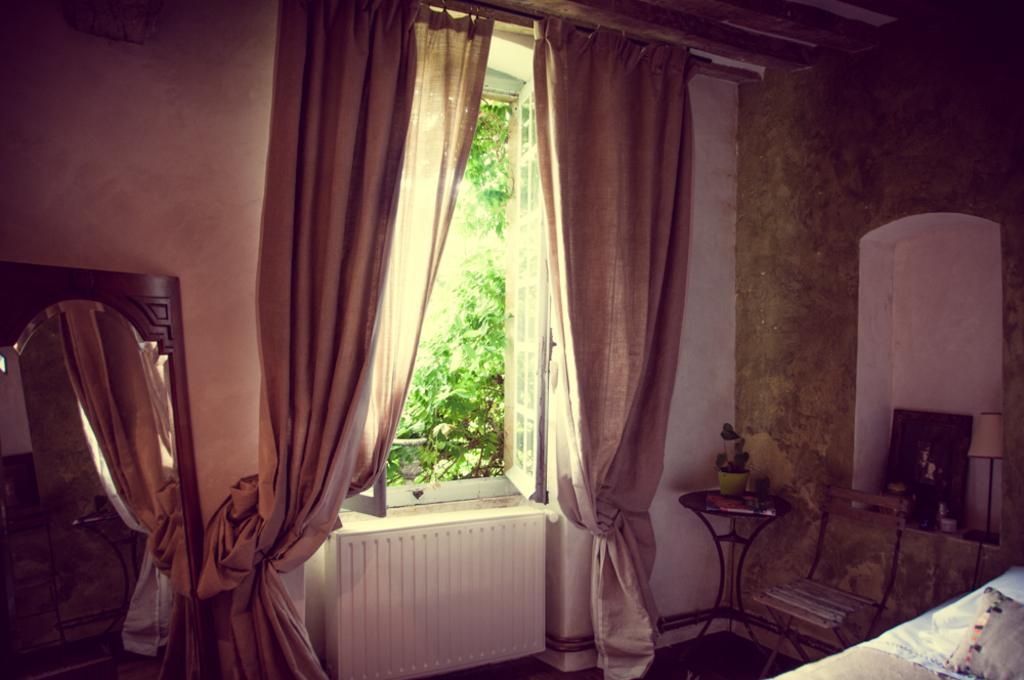What is present in the image that allows light to enter the room? There is a window in the image. What is used to cover or decorate the window? There are curtains associated with the window. What type of furniture is present in the image? There is a chair and a table in the image. What can be seen in the background of the image? Green plants are visible in the background of the image. What type of wheel is visible in the image? There is no wheel present in the image. Who is the uncle in the image? There is no person, let alone an uncle, present in the image. 